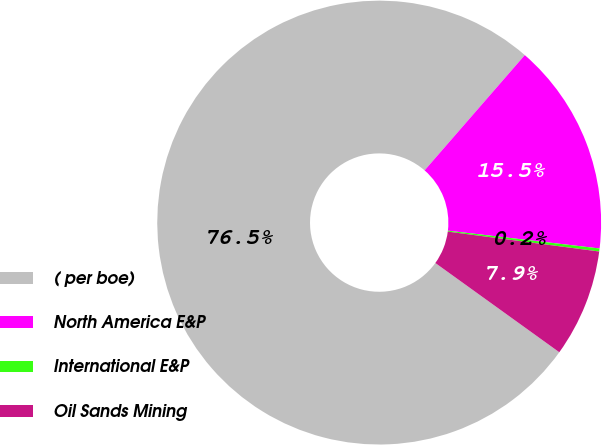Convert chart. <chart><loc_0><loc_0><loc_500><loc_500><pie_chart><fcel>( per boe)<fcel>North America E&P<fcel>International E&P<fcel>Oil Sands Mining<nl><fcel>76.46%<fcel>15.47%<fcel>0.22%<fcel>7.85%<nl></chart> 